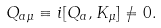<formula> <loc_0><loc_0><loc_500><loc_500>Q _ { a \mu } \equiv i [ Q _ { a } , K _ { \mu } ] \ne 0 .</formula> 